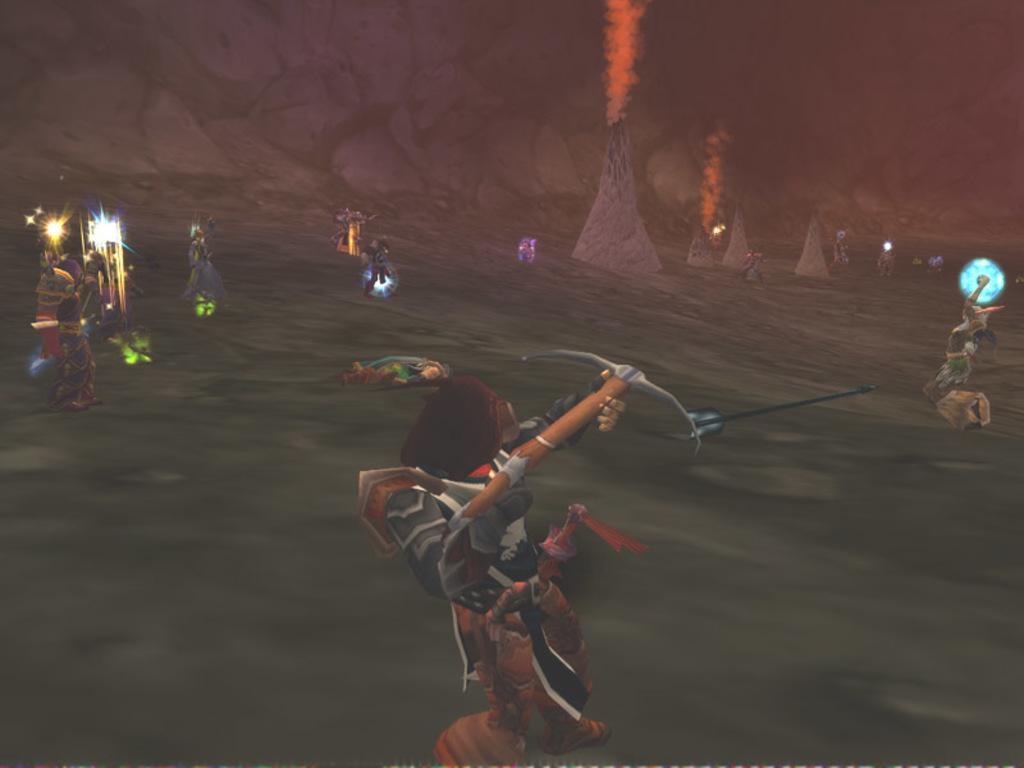Can you describe this image briefly? It is an animated image, in the middle a man is shooting the arrows with a bow. On the left side there are lights and few other men are also fighting, at the back side there are volcanoes. 